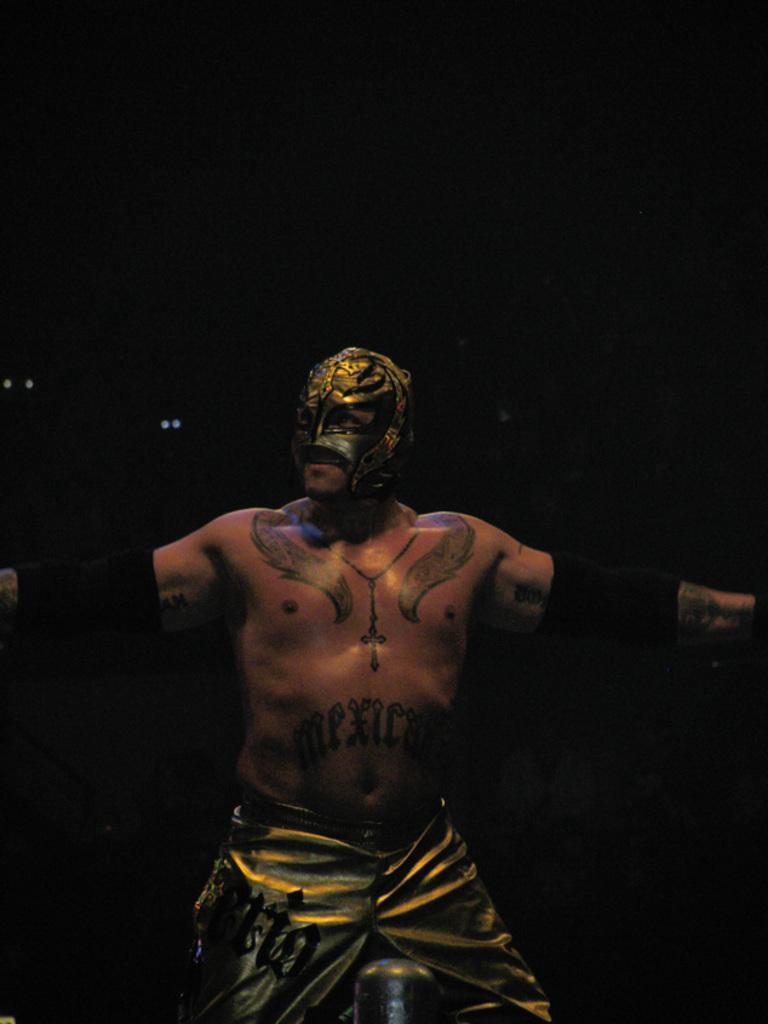Please provide a concise description of this image. In this picture there is a man standing and there is a text and there are tattoos on his body and he is wearing a mask. At the back there is a black background. 